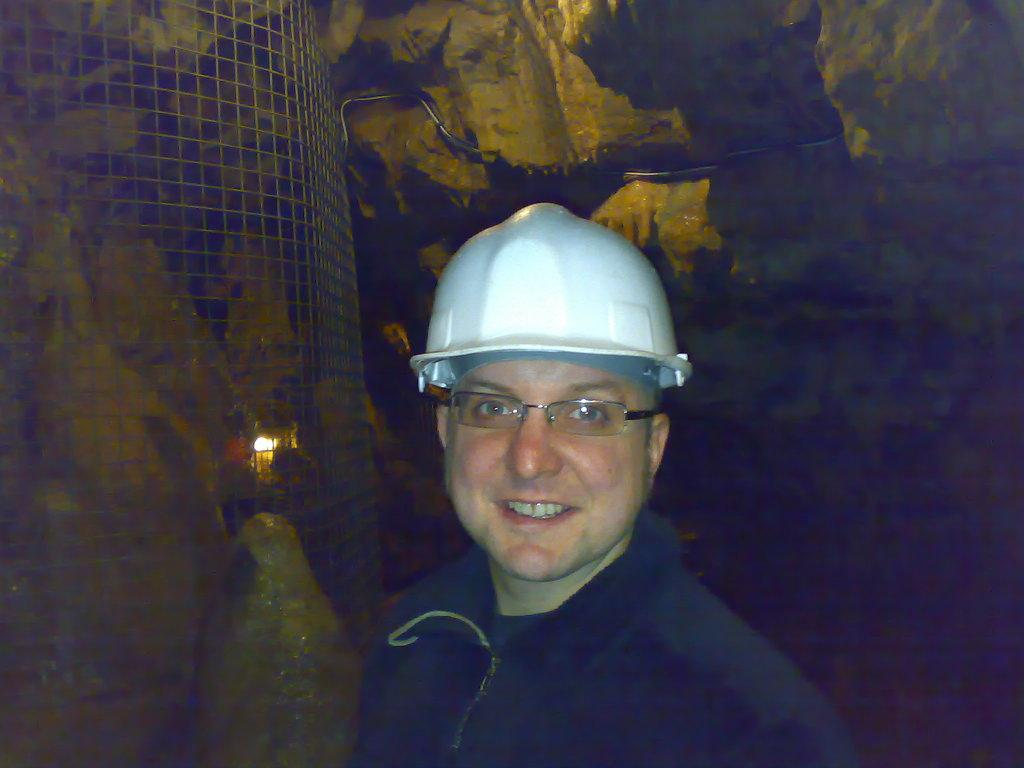Who is present in the image? There is a man in the image. What is the man wearing on his head? The man is wearing a white helmet. What can be seen in the foreground of the image? There is fencing visible in the image. What is the color of the background in the image? The background of the image appears to be dark. What type of tree can be seen in the background of the image? There is no tree visible in the background of the image; it appears to be dark. Is there a party happening in the image? There is no indication of a party in the image; it only features a man wearing a white helmet and fencing in the foreground. 